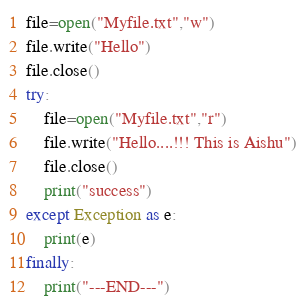<code> <loc_0><loc_0><loc_500><loc_500><_Python_>file=open("Myfile.txt","w")
file.write("Hello")
file.close()
try:
    file=open("Myfile.txt","r")
    file.write("Hello....!!! This is Aishu")
    file.close()
    print("success")
except Exception as e:
    print(e)
finally:
    print("---END---")</code> 